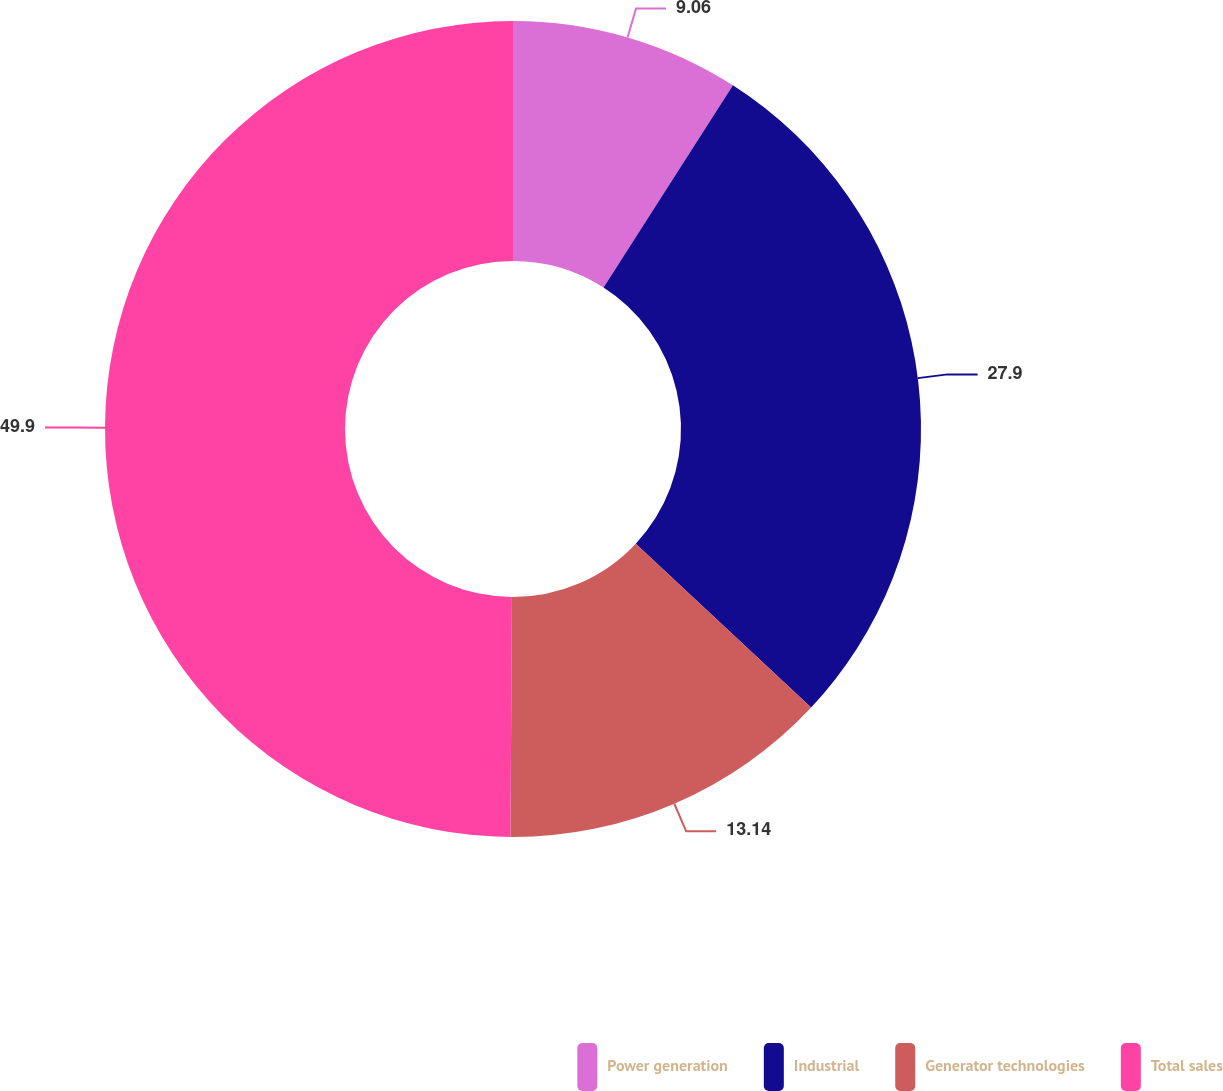Convert chart to OTSL. <chart><loc_0><loc_0><loc_500><loc_500><pie_chart><fcel>Power generation<fcel>Industrial<fcel>Generator technologies<fcel>Total sales<nl><fcel>9.06%<fcel>27.9%<fcel>13.14%<fcel>49.9%<nl></chart> 